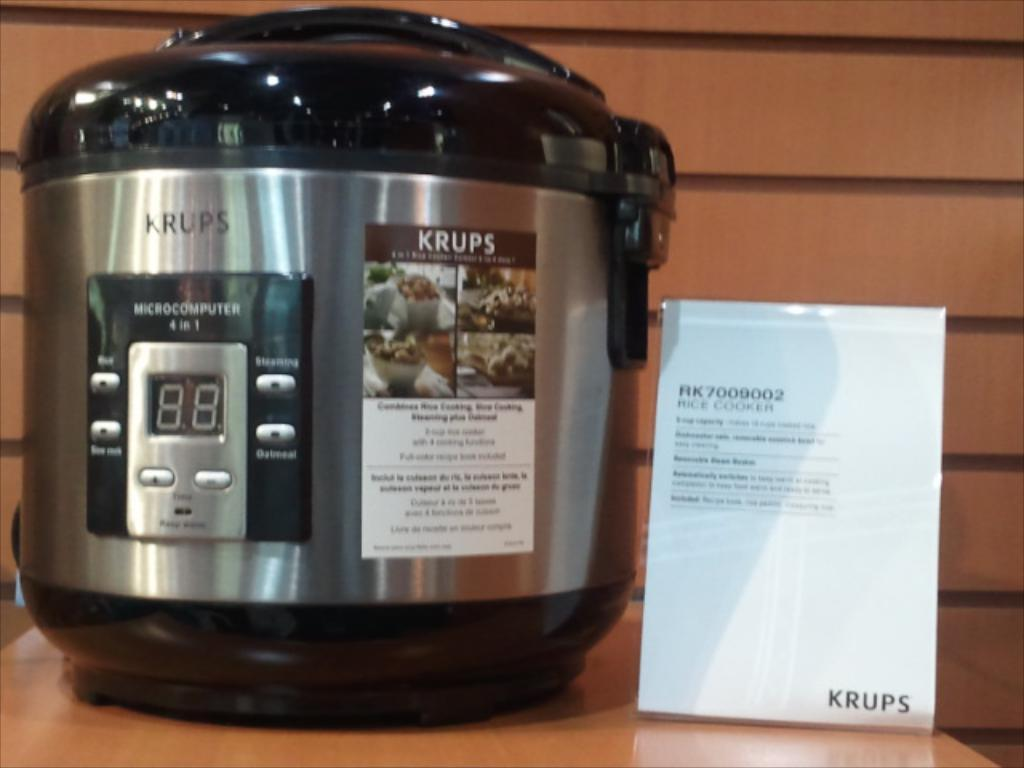<image>
Share a concise interpretation of the image provided. A pressure cooker that is for sale is on a shelf. 